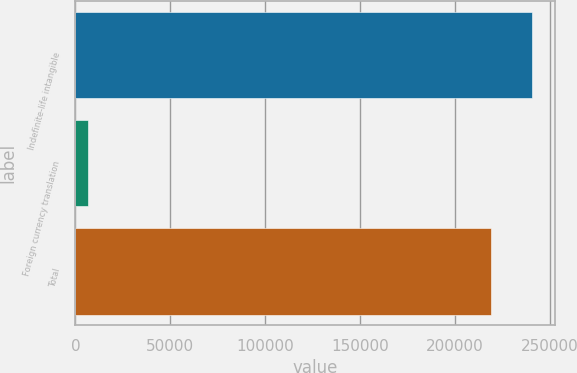<chart> <loc_0><loc_0><loc_500><loc_500><bar_chart><fcel>Indefinite-life intangible<fcel>Foreign currency translation<fcel>Total<nl><fcel>240771<fcel>6796<fcel>218883<nl></chart> 